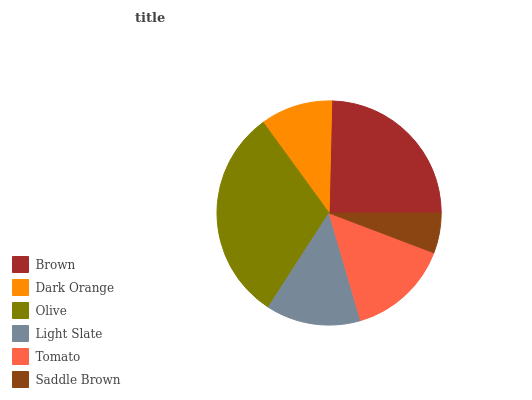Is Saddle Brown the minimum?
Answer yes or no. Yes. Is Olive the maximum?
Answer yes or no. Yes. Is Dark Orange the minimum?
Answer yes or no. No. Is Dark Orange the maximum?
Answer yes or no. No. Is Brown greater than Dark Orange?
Answer yes or no. Yes. Is Dark Orange less than Brown?
Answer yes or no. Yes. Is Dark Orange greater than Brown?
Answer yes or no. No. Is Brown less than Dark Orange?
Answer yes or no. No. Is Tomato the high median?
Answer yes or no. Yes. Is Light Slate the low median?
Answer yes or no. Yes. Is Saddle Brown the high median?
Answer yes or no. No. Is Brown the low median?
Answer yes or no. No. 